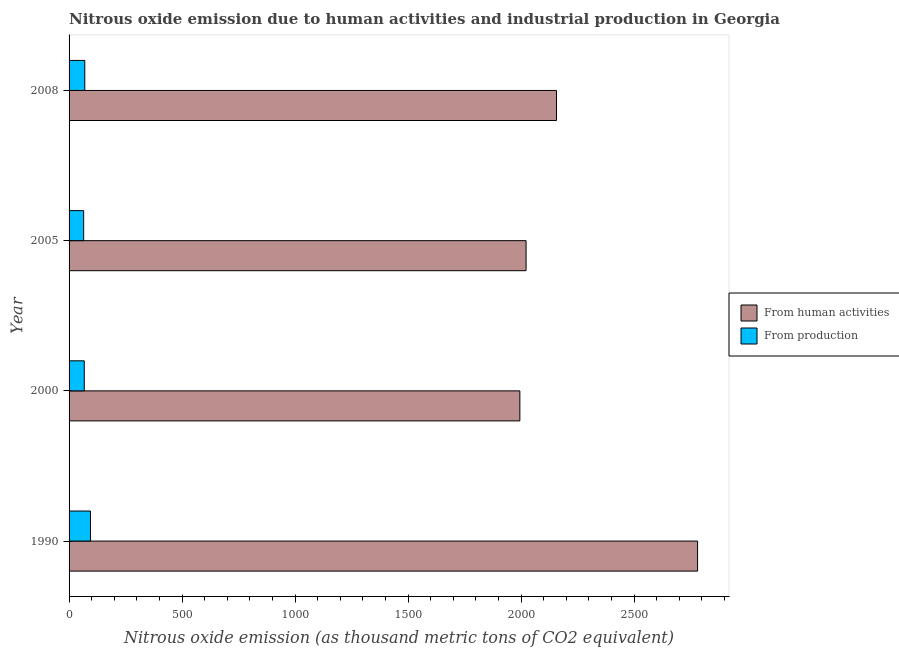How many different coloured bars are there?
Make the answer very short. 2. How many groups of bars are there?
Keep it short and to the point. 4. Are the number of bars per tick equal to the number of legend labels?
Your answer should be compact. Yes. How many bars are there on the 1st tick from the top?
Your answer should be very brief. 2. How many bars are there on the 1st tick from the bottom?
Keep it short and to the point. 2. What is the label of the 1st group of bars from the top?
Your answer should be compact. 2008. In how many cases, is the number of bars for a given year not equal to the number of legend labels?
Your answer should be very brief. 0. What is the amount of emissions generated from industries in 1990?
Your answer should be compact. 94.9. Across all years, what is the maximum amount of emissions generated from industries?
Your answer should be very brief. 94.9. Across all years, what is the minimum amount of emissions from human activities?
Keep it short and to the point. 1994.5. In which year was the amount of emissions generated from industries minimum?
Provide a succinct answer. 2005. What is the total amount of emissions generated from industries in the graph?
Give a very brief answer. 296.1. What is the difference between the amount of emissions generated from industries in 2000 and that in 2005?
Ensure brevity in your answer.  2.7. What is the difference between the amount of emissions from human activities in 2000 and the amount of emissions generated from industries in 1990?
Your answer should be compact. 1899.6. What is the average amount of emissions from human activities per year?
Offer a terse response. 2238.47. In the year 2005, what is the difference between the amount of emissions generated from industries and amount of emissions from human activities?
Provide a short and direct response. -1957.5. In how many years, is the amount of emissions generated from industries greater than 2200 thousand metric tons?
Your answer should be compact. 0. Is the difference between the amount of emissions from human activities in 2000 and 2008 greater than the difference between the amount of emissions generated from industries in 2000 and 2008?
Provide a succinct answer. No. What is the difference between the highest and the second highest amount of emissions from human activities?
Your answer should be very brief. 624.2. What is the difference between the highest and the lowest amount of emissions from human activities?
Make the answer very short. 786.3. In how many years, is the amount of emissions generated from industries greater than the average amount of emissions generated from industries taken over all years?
Offer a terse response. 1. What does the 2nd bar from the top in 2008 represents?
Provide a succinct answer. From human activities. What does the 2nd bar from the bottom in 2008 represents?
Your answer should be compact. From production. How many bars are there?
Keep it short and to the point. 8. Are all the bars in the graph horizontal?
Provide a succinct answer. Yes. What is the difference between two consecutive major ticks on the X-axis?
Give a very brief answer. 500. Are the values on the major ticks of X-axis written in scientific E-notation?
Your answer should be compact. No. Does the graph contain any zero values?
Offer a terse response. No. Where does the legend appear in the graph?
Give a very brief answer. Center right. How many legend labels are there?
Offer a very short reply. 2. What is the title of the graph?
Offer a very short reply. Nitrous oxide emission due to human activities and industrial production in Georgia. What is the label or title of the X-axis?
Ensure brevity in your answer.  Nitrous oxide emission (as thousand metric tons of CO2 equivalent). What is the label or title of the Y-axis?
Provide a succinct answer. Year. What is the Nitrous oxide emission (as thousand metric tons of CO2 equivalent) in From human activities in 1990?
Ensure brevity in your answer.  2780.8. What is the Nitrous oxide emission (as thousand metric tons of CO2 equivalent) of From production in 1990?
Offer a terse response. 94.9. What is the Nitrous oxide emission (as thousand metric tons of CO2 equivalent) in From human activities in 2000?
Your answer should be very brief. 1994.5. What is the Nitrous oxide emission (as thousand metric tons of CO2 equivalent) in From production in 2000?
Offer a very short reply. 67.2. What is the Nitrous oxide emission (as thousand metric tons of CO2 equivalent) in From human activities in 2005?
Provide a short and direct response. 2022. What is the Nitrous oxide emission (as thousand metric tons of CO2 equivalent) of From production in 2005?
Offer a terse response. 64.5. What is the Nitrous oxide emission (as thousand metric tons of CO2 equivalent) in From human activities in 2008?
Give a very brief answer. 2156.6. What is the Nitrous oxide emission (as thousand metric tons of CO2 equivalent) of From production in 2008?
Offer a terse response. 69.5. Across all years, what is the maximum Nitrous oxide emission (as thousand metric tons of CO2 equivalent) of From human activities?
Your answer should be very brief. 2780.8. Across all years, what is the maximum Nitrous oxide emission (as thousand metric tons of CO2 equivalent) in From production?
Your response must be concise. 94.9. Across all years, what is the minimum Nitrous oxide emission (as thousand metric tons of CO2 equivalent) of From human activities?
Provide a short and direct response. 1994.5. Across all years, what is the minimum Nitrous oxide emission (as thousand metric tons of CO2 equivalent) of From production?
Your answer should be very brief. 64.5. What is the total Nitrous oxide emission (as thousand metric tons of CO2 equivalent) of From human activities in the graph?
Make the answer very short. 8953.9. What is the total Nitrous oxide emission (as thousand metric tons of CO2 equivalent) of From production in the graph?
Provide a succinct answer. 296.1. What is the difference between the Nitrous oxide emission (as thousand metric tons of CO2 equivalent) of From human activities in 1990 and that in 2000?
Give a very brief answer. 786.3. What is the difference between the Nitrous oxide emission (as thousand metric tons of CO2 equivalent) of From production in 1990 and that in 2000?
Provide a succinct answer. 27.7. What is the difference between the Nitrous oxide emission (as thousand metric tons of CO2 equivalent) of From human activities in 1990 and that in 2005?
Your answer should be compact. 758.8. What is the difference between the Nitrous oxide emission (as thousand metric tons of CO2 equivalent) in From production in 1990 and that in 2005?
Provide a succinct answer. 30.4. What is the difference between the Nitrous oxide emission (as thousand metric tons of CO2 equivalent) in From human activities in 1990 and that in 2008?
Provide a short and direct response. 624.2. What is the difference between the Nitrous oxide emission (as thousand metric tons of CO2 equivalent) in From production in 1990 and that in 2008?
Keep it short and to the point. 25.4. What is the difference between the Nitrous oxide emission (as thousand metric tons of CO2 equivalent) of From human activities in 2000 and that in 2005?
Provide a succinct answer. -27.5. What is the difference between the Nitrous oxide emission (as thousand metric tons of CO2 equivalent) of From production in 2000 and that in 2005?
Make the answer very short. 2.7. What is the difference between the Nitrous oxide emission (as thousand metric tons of CO2 equivalent) of From human activities in 2000 and that in 2008?
Provide a short and direct response. -162.1. What is the difference between the Nitrous oxide emission (as thousand metric tons of CO2 equivalent) of From human activities in 2005 and that in 2008?
Offer a terse response. -134.6. What is the difference between the Nitrous oxide emission (as thousand metric tons of CO2 equivalent) in From human activities in 1990 and the Nitrous oxide emission (as thousand metric tons of CO2 equivalent) in From production in 2000?
Your answer should be very brief. 2713.6. What is the difference between the Nitrous oxide emission (as thousand metric tons of CO2 equivalent) of From human activities in 1990 and the Nitrous oxide emission (as thousand metric tons of CO2 equivalent) of From production in 2005?
Give a very brief answer. 2716.3. What is the difference between the Nitrous oxide emission (as thousand metric tons of CO2 equivalent) of From human activities in 1990 and the Nitrous oxide emission (as thousand metric tons of CO2 equivalent) of From production in 2008?
Your answer should be very brief. 2711.3. What is the difference between the Nitrous oxide emission (as thousand metric tons of CO2 equivalent) of From human activities in 2000 and the Nitrous oxide emission (as thousand metric tons of CO2 equivalent) of From production in 2005?
Ensure brevity in your answer.  1930. What is the difference between the Nitrous oxide emission (as thousand metric tons of CO2 equivalent) of From human activities in 2000 and the Nitrous oxide emission (as thousand metric tons of CO2 equivalent) of From production in 2008?
Give a very brief answer. 1925. What is the difference between the Nitrous oxide emission (as thousand metric tons of CO2 equivalent) of From human activities in 2005 and the Nitrous oxide emission (as thousand metric tons of CO2 equivalent) of From production in 2008?
Provide a short and direct response. 1952.5. What is the average Nitrous oxide emission (as thousand metric tons of CO2 equivalent) in From human activities per year?
Provide a short and direct response. 2238.47. What is the average Nitrous oxide emission (as thousand metric tons of CO2 equivalent) of From production per year?
Provide a short and direct response. 74.03. In the year 1990, what is the difference between the Nitrous oxide emission (as thousand metric tons of CO2 equivalent) in From human activities and Nitrous oxide emission (as thousand metric tons of CO2 equivalent) in From production?
Your answer should be compact. 2685.9. In the year 2000, what is the difference between the Nitrous oxide emission (as thousand metric tons of CO2 equivalent) in From human activities and Nitrous oxide emission (as thousand metric tons of CO2 equivalent) in From production?
Ensure brevity in your answer.  1927.3. In the year 2005, what is the difference between the Nitrous oxide emission (as thousand metric tons of CO2 equivalent) of From human activities and Nitrous oxide emission (as thousand metric tons of CO2 equivalent) of From production?
Offer a very short reply. 1957.5. In the year 2008, what is the difference between the Nitrous oxide emission (as thousand metric tons of CO2 equivalent) of From human activities and Nitrous oxide emission (as thousand metric tons of CO2 equivalent) of From production?
Provide a succinct answer. 2087.1. What is the ratio of the Nitrous oxide emission (as thousand metric tons of CO2 equivalent) of From human activities in 1990 to that in 2000?
Keep it short and to the point. 1.39. What is the ratio of the Nitrous oxide emission (as thousand metric tons of CO2 equivalent) of From production in 1990 to that in 2000?
Your answer should be compact. 1.41. What is the ratio of the Nitrous oxide emission (as thousand metric tons of CO2 equivalent) in From human activities in 1990 to that in 2005?
Your answer should be compact. 1.38. What is the ratio of the Nitrous oxide emission (as thousand metric tons of CO2 equivalent) in From production in 1990 to that in 2005?
Provide a short and direct response. 1.47. What is the ratio of the Nitrous oxide emission (as thousand metric tons of CO2 equivalent) of From human activities in 1990 to that in 2008?
Your response must be concise. 1.29. What is the ratio of the Nitrous oxide emission (as thousand metric tons of CO2 equivalent) in From production in 1990 to that in 2008?
Make the answer very short. 1.37. What is the ratio of the Nitrous oxide emission (as thousand metric tons of CO2 equivalent) of From human activities in 2000 to that in 2005?
Ensure brevity in your answer.  0.99. What is the ratio of the Nitrous oxide emission (as thousand metric tons of CO2 equivalent) of From production in 2000 to that in 2005?
Keep it short and to the point. 1.04. What is the ratio of the Nitrous oxide emission (as thousand metric tons of CO2 equivalent) of From human activities in 2000 to that in 2008?
Your response must be concise. 0.92. What is the ratio of the Nitrous oxide emission (as thousand metric tons of CO2 equivalent) of From production in 2000 to that in 2008?
Offer a very short reply. 0.97. What is the ratio of the Nitrous oxide emission (as thousand metric tons of CO2 equivalent) in From human activities in 2005 to that in 2008?
Provide a succinct answer. 0.94. What is the ratio of the Nitrous oxide emission (as thousand metric tons of CO2 equivalent) in From production in 2005 to that in 2008?
Provide a succinct answer. 0.93. What is the difference between the highest and the second highest Nitrous oxide emission (as thousand metric tons of CO2 equivalent) of From human activities?
Provide a short and direct response. 624.2. What is the difference between the highest and the second highest Nitrous oxide emission (as thousand metric tons of CO2 equivalent) in From production?
Give a very brief answer. 25.4. What is the difference between the highest and the lowest Nitrous oxide emission (as thousand metric tons of CO2 equivalent) in From human activities?
Your answer should be very brief. 786.3. What is the difference between the highest and the lowest Nitrous oxide emission (as thousand metric tons of CO2 equivalent) of From production?
Offer a very short reply. 30.4. 